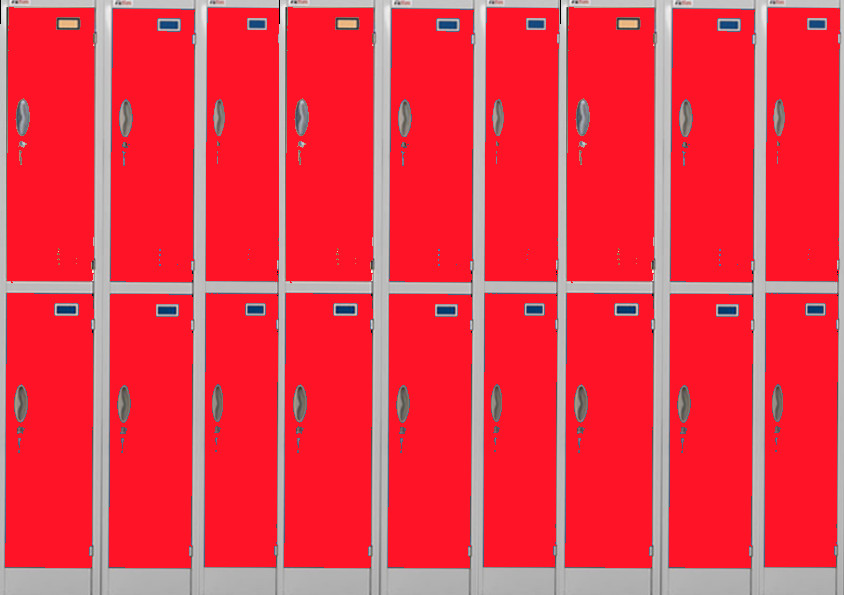This image of the red lockers with blue labels seems pretty straightforward. What do you think could happen if someone accidentally places a different color label on one of the lockers? If a different color label were placed on one of the lockers, it could easily stand out against the uniformity of the rest. This could indicate a special purpose or designation for that particular locker, whether it’s reserved for a specific individual or contains special items. Anyone familiar with the locker system would immediately notice the discrepancy and might investigate further to understand the reason behind the unique labeling. Let's imagine a magical scenario where the blue labels grant special powers. What kind of powers could they grant to the users? In a magical scenario, the blue labels could be enchanted to grant each locker user a unique power. For instance, one label might give the user the power of invisibility whenever they approach the locker, allowing them to retrieve items unseen. Another could imbue the user with super strength, making their belongings incredibly light to carry. Some labels might even grant the power of time manipulation, allowing students or employees to slow down time around them so they can complete tasks more efficiently. These magical blue labels would definitely add a layer of excitement and wonder to everyday routine activities. What if each locker represents a different character in a story, what kind of characters do you think they would be? If each locker were a character in a story, these could be immensely diverse and fascinating. The red locker with the blue label might represent a bold and dependable character who stands out for their reliability and organizational skills. Another could be a fiery and passionate individual who brings excitement to everyone around them. One locker might represent a mysterious and reserved character, guarding secrets within. Perhaps there's a locker with a slightly different shade, indicating a quirky and creative character who loves to innovate and think outside the box. Each locker would bring its unique personality and backstory to the overarching narrative, creating a rich tapestry of interconnected lives and experiences. 